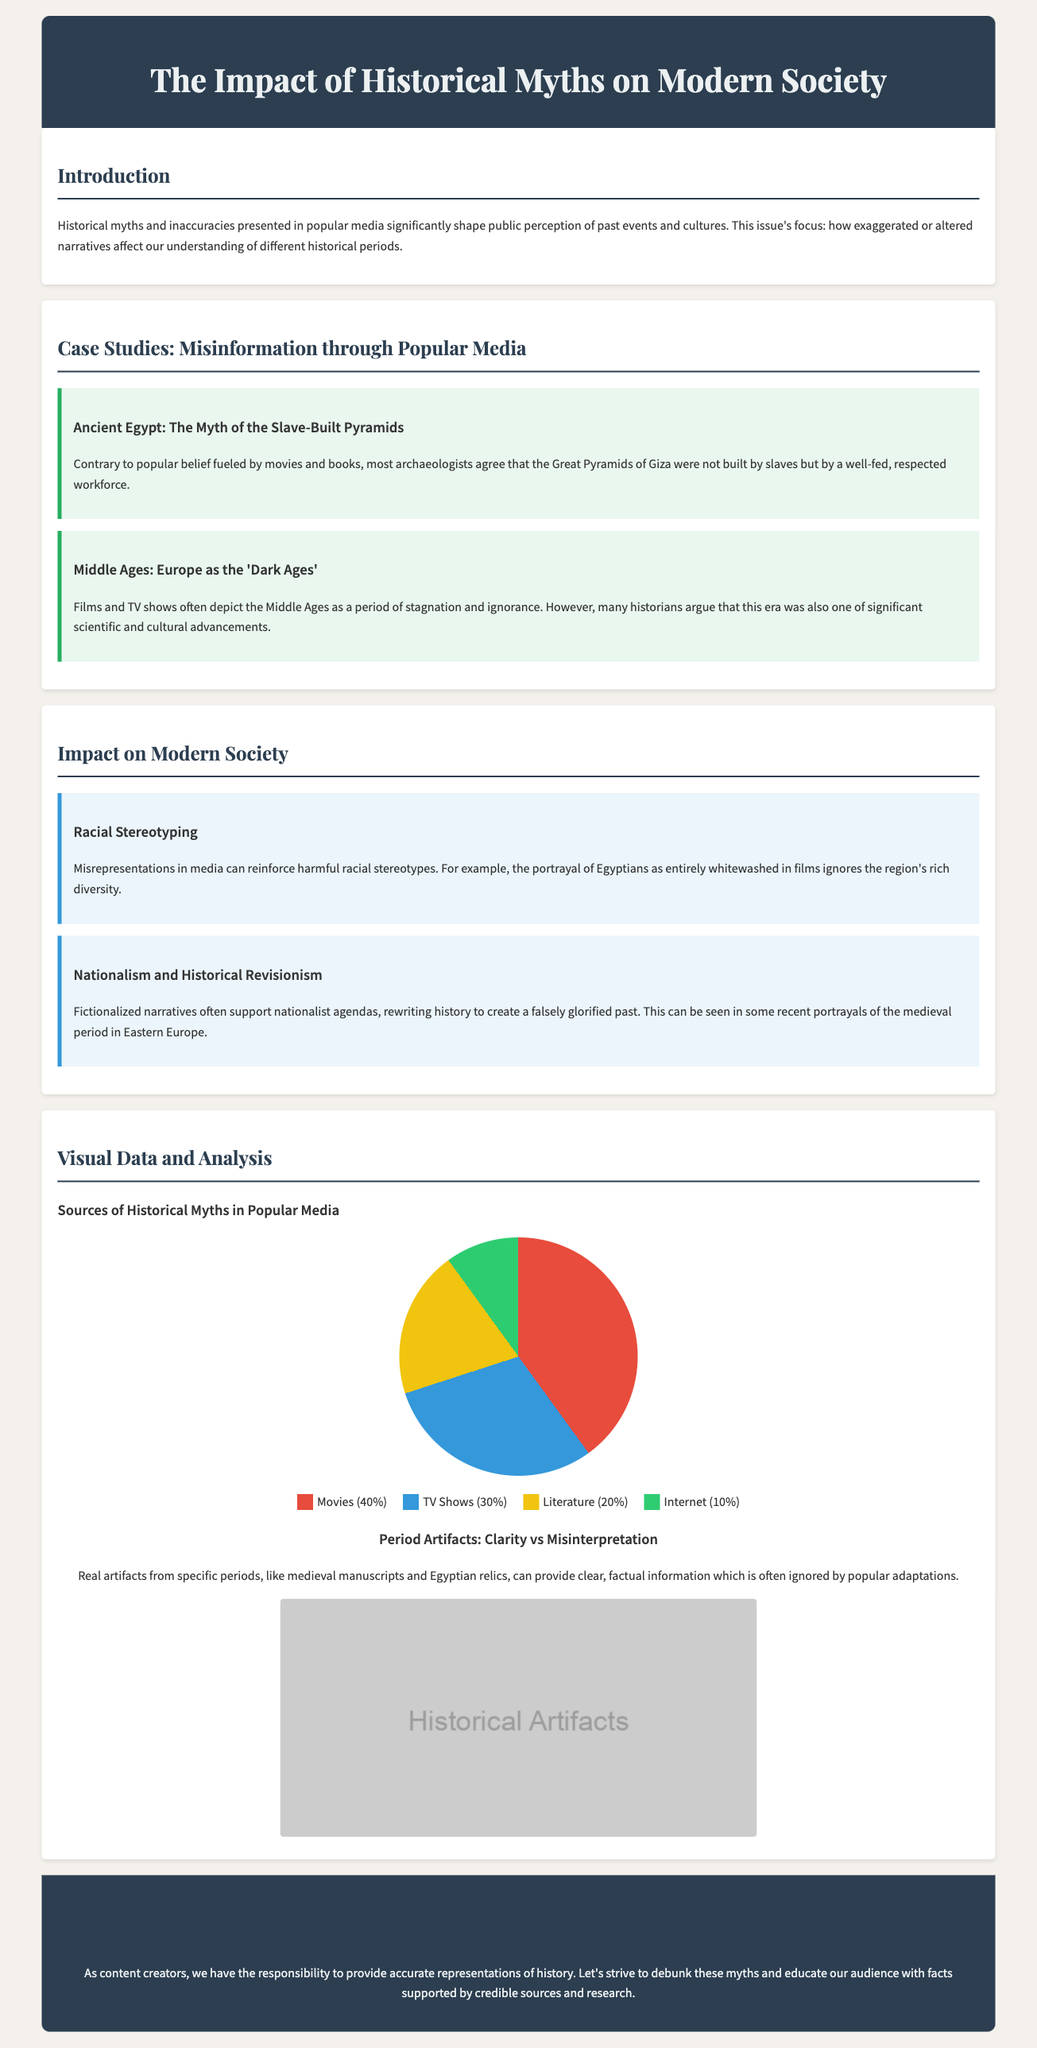What is the title of the document? The title is presented prominently at the top of the document.
Answer: The Impact of Historical Myths on Modern Society What is the focus of this issue's discussion? The focus is stated in the introduction section of the document.
Answer: How exaggerated or altered narratives affect our understanding of different historical periods What percentage of historical myths come from movies? The document provides a breakdown of sources for historical myths in the pie chart.
Answer: 40% What is one case study mentioned related to Ancient Egypt? The case study section outlines specific myths and inaccuracies about historical periods.
Answer: The Myth of the Slave-Built Pyramids What type of artifacts are discussed as providing clarity? The artifacts section specifies the types of artifacts being referenced.
Answer: Medieval manuscripts and Egyptian relics What impact on modern society is raised concerning racial stereotyping? The impact section discusses various modern societal issues stemming from historical inaccuracies.
Answer: Misrepresentations in media can reinforce harmful racial stereotypes What are the primary sources of historical myths according to the pie chart? The pie chart categorizes the sources of historical myths for easy identification.
Answer: Movies, TV Shows, Literature, and Internet What is included in the call to action? The call to action section emphasizes the responsibilities of content creators.
Answer: Strive to debunk these myths and educate our audience with facts supported by credible sources and research 